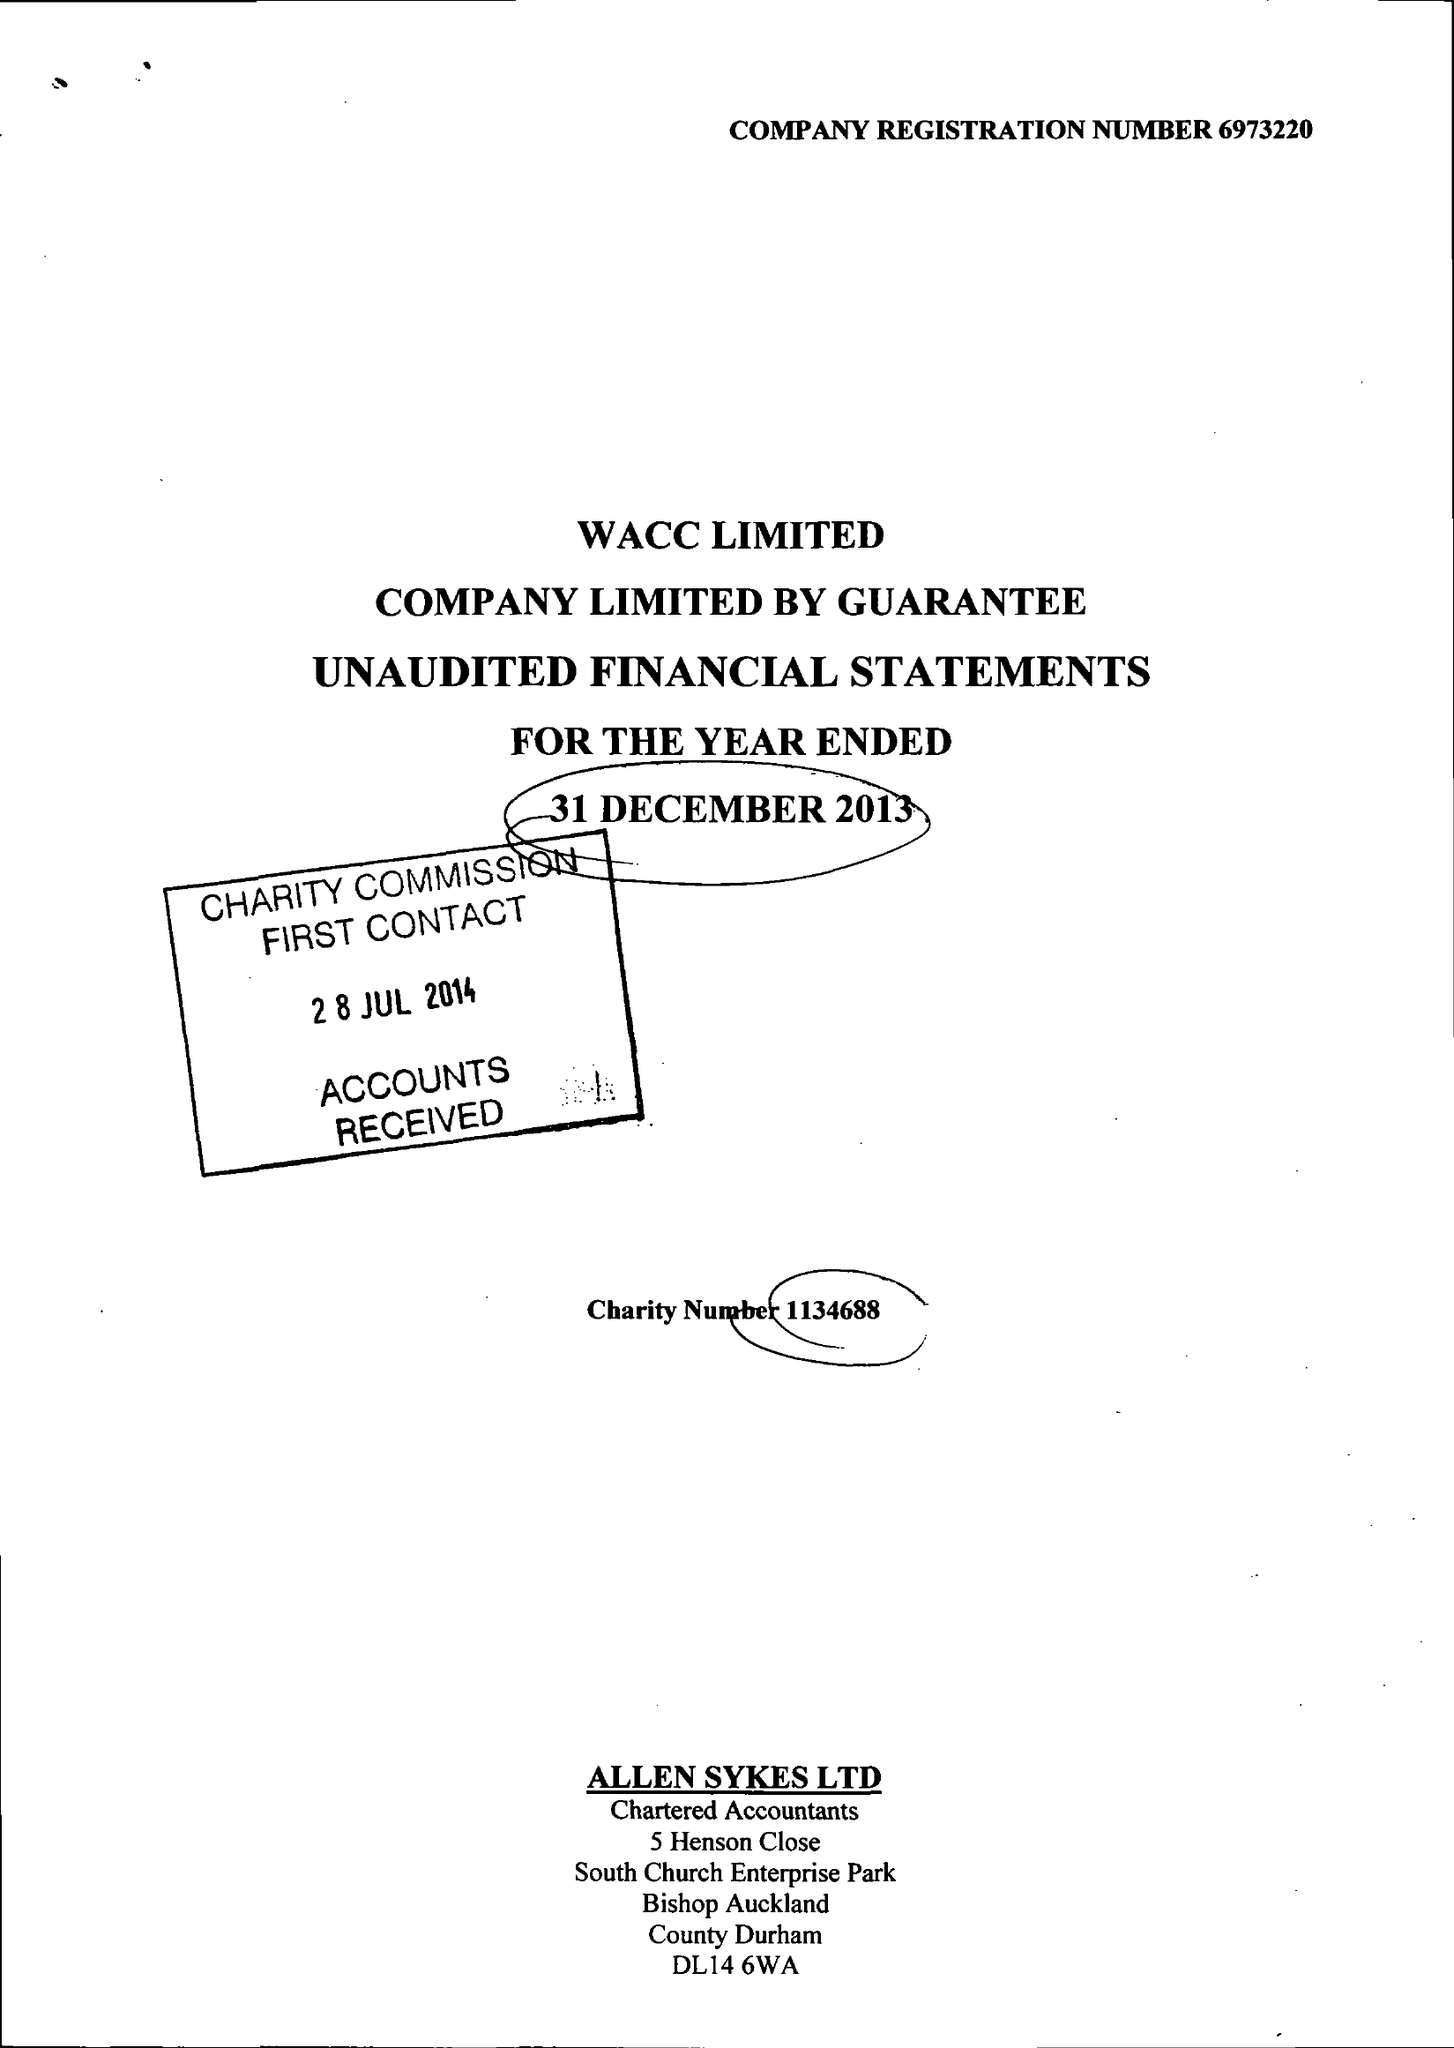What is the value for the report_date?
Answer the question using a single word or phrase. 2013-12-31 